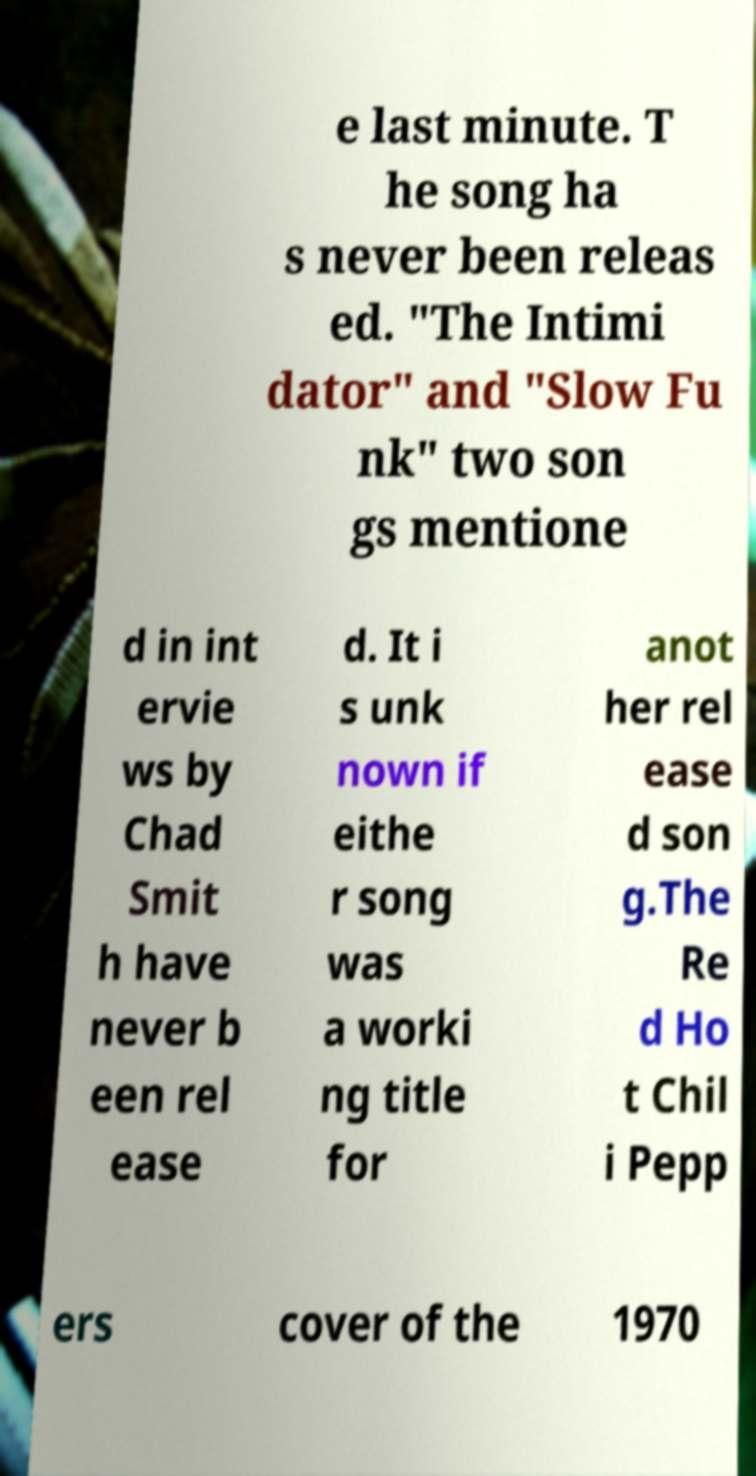Could you assist in decoding the text presented in this image and type it out clearly? e last minute. T he song ha s never been releas ed. "The Intimi dator" and "Slow Fu nk" two son gs mentione d in int ervie ws by Chad Smit h have never b een rel ease d. It i s unk nown if eithe r song was a worki ng title for anot her rel ease d son g.The Re d Ho t Chil i Pepp ers cover of the 1970 